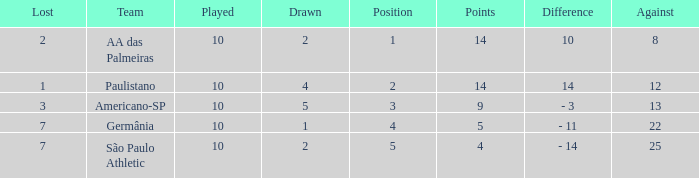What is the sum of Against when the lost is more than 7? None. Could you help me parse every detail presented in this table? {'header': ['Lost', 'Team', 'Played', 'Drawn', 'Position', 'Points', 'Difference', 'Against'], 'rows': [['2', 'AA das Palmeiras', '10', '2', '1', '14', '10', '8'], ['1', 'Paulistano', '10', '4', '2', '14', '14', '12'], ['3', 'Americano-SP', '10', '5', '3', '9', '- 3', '13'], ['7', 'Germânia', '10', '1', '4', '5', '- 11', '22'], ['7', 'São Paulo Athletic', '10', '2', '5', '4', '- 14', '25']]} 